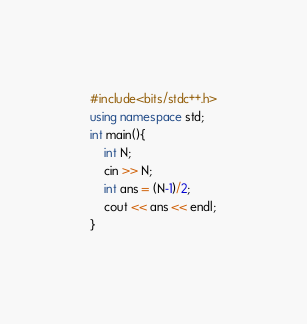Convert code to text. <code><loc_0><loc_0><loc_500><loc_500><_C++_>#include<bits/stdc++.h>
using namespace std;
int main(){
    int N;
    cin >> N;
    int ans = (N-1)/2;
    cout << ans << endl;
}

</code> 